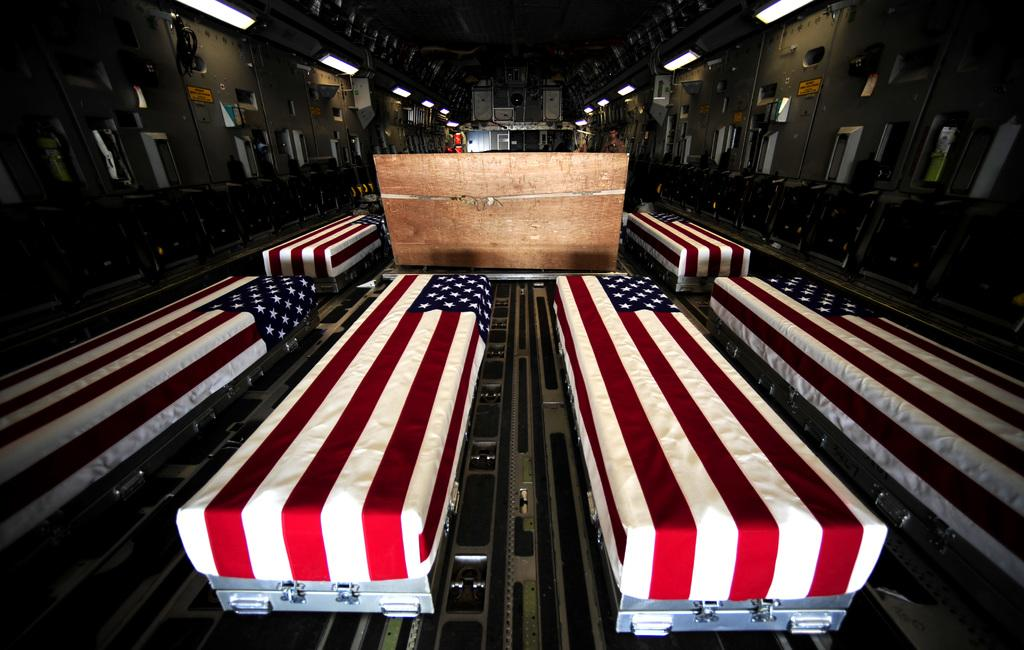What is the main subject of the picture? The main subject of the picture is many boxes. What is covering the boxes? The boxes are covered with American flags. Can you describe the setting of the picture? The boxes are kept in a dark room. What type of sponge is used to clean the boxes in the image? There is no sponge present in the image, and the boxes are not being cleaned. 